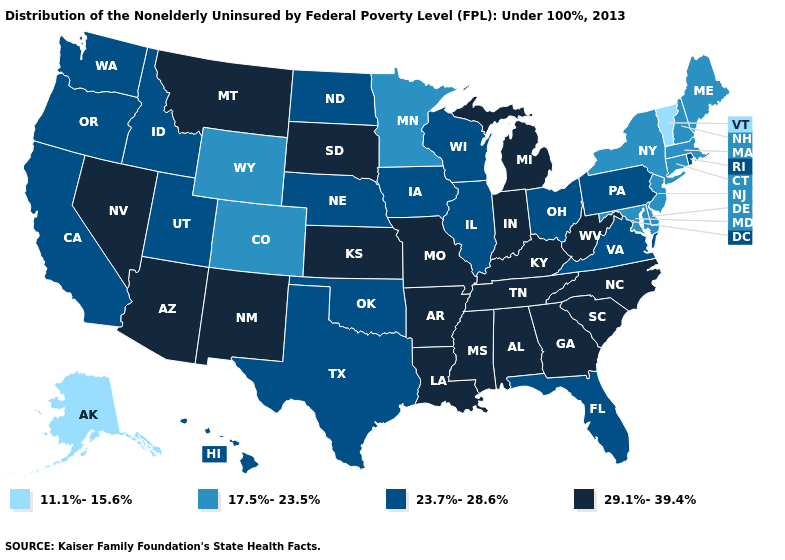Name the states that have a value in the range 23.7%-28.6%?
Be succinct. California, Florida, Hawaii, Idaho, Illinois, Iowa, Nebraska, North Dakota, Ohio, Oklahoma, Oregon, Pennsylvania, Rhode Island, Texas, Utah, Virginia, Washington, Wisconsin. Is the legend a continuous bar?
Give a very brief answer. No. Among the states that border West Virginia , does Ohio have the lowest value?
Keep it brief. No. Does Missouri have the lowest value in the MidWest?
Quick response, please. No. Name the states that have a value in the range 17.5%-23.5%?
Give a very brief answer. Colorado, Connecticut, Delaware, Maine, Maryland, Massachusetts, Minnesota, New Hampshire, New Jersey, New York, Wyoming. How many symbols are there in the legend?
Concise answer only. 4. Which states hav the highest value in the Northeast?
Write a very short answer. Pennsylvania, Rhode Island. Name the states that have a value in the range 29.1%-39.4%?
Write a very short answer. Alabama, Arizona, Arkansas, Georgia, Indiana, Kansas, Kentucky, Louisiana, Michigan, Mississippi, Missouri, Montana, Nevada, New Mexico, North Carolina, South Carolina, South Dakota, Tennessee, West Virginia. What is the value of New York?
Short answer required. 17.5%-23.5%. Which states hav the highest value in the South?
Answer briefly. Alabama, Arkansas, Georgia, Kentucky, Louisiana, Mississippi, North Carolina, South Carolina, Tennessee, West Virginia. What is the highest value in the MidWest ?
Write a very short answer. 29.1%-39.4%. Among the states that border New Mexico , does Arizona have the highest value?
Short answer required. Yes. Which states hav the highest value in the Northeast?
Quick response, please. Pennsylvania, Rhode Island. Does the map have missing data?
Write a very short answer. No. What is the value of Rhode Island?
Quick response, please. 23.7%-28.6%. 